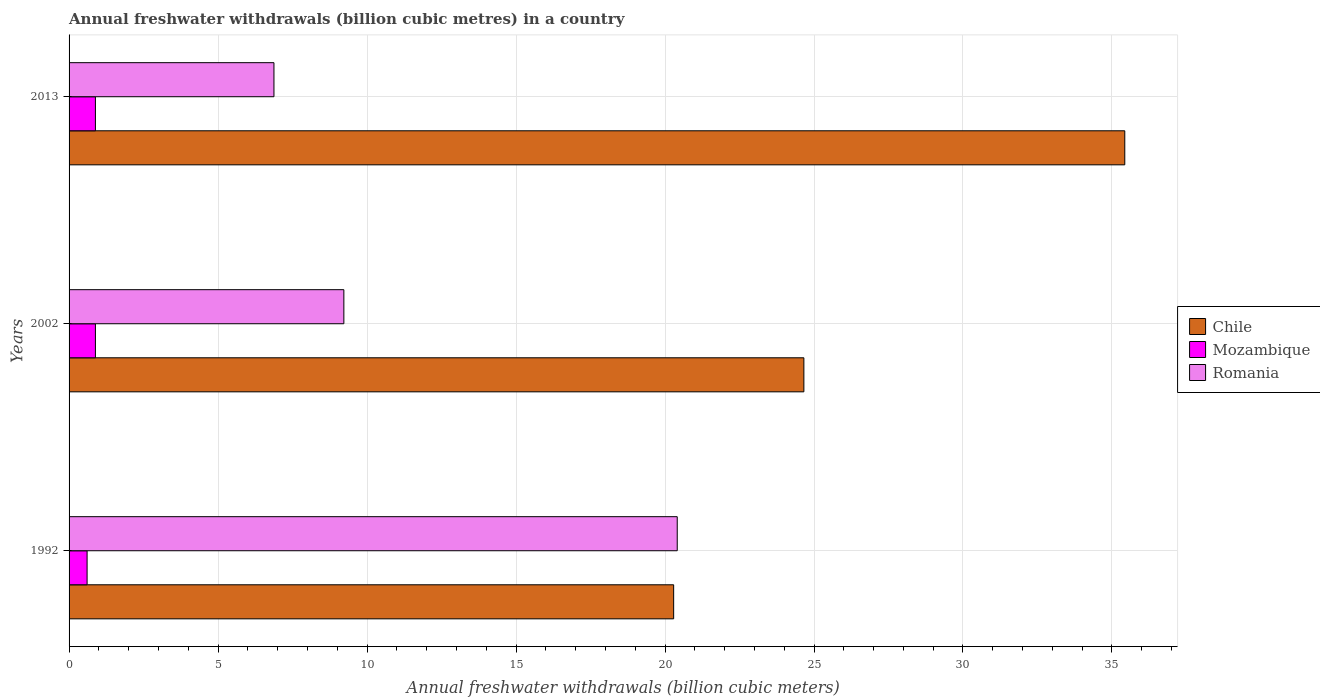How many different coloured bars are there?
Provide a succinct answer. 3. What is the annual freshwater withdrawals in Romania in 2013?
Provide a succinct answer. 6.88. Across all years, what is the maximum annual freshwater withdrawals in Mozambique?
Your answer should be very brief. 0.88. Across all years, what is the minimum annual freshwater withdrawals in Mozambique?
Ensure brevity in your answer.  0.6. In which year was the annual freshwater withdrawals in Romania minimum?
Offer a very short reply. 2013. What is the total annual freshwater withdrawals in Chile in the graph?
Provide a succinct answer. 80.38. What is the difference between the annual freshwater withdrawals in Chile in 1992 and that in 2002?
Make the answer very short. -4.37. What is the difference between the annual freshwater withdrawals in Romania in 2013 and the annual freshwater withdrawals in Chile in 2002?
Give a very brief answer. -17.78. What is the average annual freshwater withdrawals in Chile per year?
Provide a succinct answer. 26.79. In the year 1992, what is the difference between the annual freshwater withdrawals in Romania and annual freshwater withdrawals in Chile?
Your answer should be compact. 0.12. Is the annual freshwater withdrawals in Mozambique in 1992 less than that in 2002?
Your response must be concise. Yes. Is the difference between the annual freshwater withdrawals in Romania in 1992 and 2002 greater than the difference between the annual freshwater withdrawals in Chile in 1992 and 2002?
Provide a succinct answer. Yes. What is the difference between the highest and the second highest annual freshwater withdrawals in Chile?
Provide a short and direct response. 10.77. What is the difference between the highest and the lowest annual freshwater withdrawals in Chile?
Provide a succinct answer. 15.14. In how many years, is the annual freshwater withdrawals in Mozambique greater than the average annual freshwater withdrawals in Mozambique taken over all years?
Provide a short and direct response. 2. What does the 3rd bar from the bottom in 2013 represents?
Your answer should be compact. Romania. Is it the case that in every year, the sum of the annual freshwater withdrawals in Romania and annual freshwater withdrawals in Mozambique is greater than the annual freshwater withdrawals in Chile?
Make the answer very short. No. Are all the bars in the graph horizontal?
Offer a terse response. Yes. How many years are there in the graph?
Make the answer very short. 3. Are the values on the major ticks of X-axis written in scientific E-notation?
Provide a short and direct response. No. Does the graph contain any zero values?
Make the answer very short. No. Does the graph contain grids?
Provide a succinct answer. Yes. Where does the legend appear in the graph?
Offer a terse response. Center right. What is the title of the graph?
Your answer should be compact. Annual freshwater withdrawals (billion cubic metres) in a country. Does "Cameroon" appear as one of the legend labels in the graph?
Ensure brevity in your answer.  No. What is the label or title of the X-axis?
Offer a terse response. Annual freshwater withdrawals (billion cubic meters). What is the label or title of the Y-axis?
Offer a very short reply. Years. What is the Annual freshwater withdrawals (billion cubic meters) of Chile in 1992?
Offer a very short reply. 20.29. What is the Annual freshwater withdrawals (billion cubic meters) in Mozambique in 1992?
Ensure brevity in your answer.  0.6. What is the Annual freshwater withdrawals (billion cubic meters) of Romania in 1992?
Give a very brief answer. 20.41. What is the Annual freshwater withdrawals (billion cubic meters) in Chile in 2002?
Keep it short and to the point. 24.66. What is the Annual freshwater withdrawals (billion cubic meters) in Mozambique in 2002?
Provide a succinct answer. 0.88. What is the Annual freshwater withdrawals (billion cubic meters) in Romania in 2002?
Offer a terse response. 9.22. What is the Annual freshwater withdrawals (billion cubic meters) in Chile in 2013?
Provide a succinct answer. 35.43. What is the Annual freshwater withdrawals (billion cubic meters) of Mozambique in 2013?
Provide a short and direct response. 0.88. What is the Annual freshwater withdrawals (billion cubic meters) of Romania in 2013?
Your answer should be compact. 6.88. Across all years, what is the maximum Annual freshwater withdrawals (billion cubic meters) in Chile?
Keep it short and to the point. 35.43. Across all years, what is the maximum Annual freshwater withdrawals (billion cubic meters) in Mozambique?
Offer a very short reply. 0.88. Across all years, what is the maximum Annual freshwater withdrawals (billion cubic meters) in Romania?
Ensure brevity in your answer.  20.41. Across all years, what is the minimum Annual freshwater withdrawals (billion cubic meters) of Chile?
Provide a succinct answer. 20.29. Across all years, what is the minimum Annual freshwater withdrawals (billion cubic meters) in Mozambique?
Make the answer very short. 0.6. Across all years, what is the minimum Annual freshwater withdrawals (billion cubic meters) of Romania?
Provide a succinct answer. 6.88. What is the total Annual freshwater withdrawals (billion cubic meters) in Chile in the graph?
Your answer should be compact. 80.38. What is the total Annual freshwater withdrawals (billion cubic meters) of Mozambique in the graph?
Provide a succinct answer. 2.37. What is the total Annual freshwater withdrawals (billion cubic meters) of Romania in the graph?
Your answer should be very brief. 36.51. What is the difference between the Annual freshwater withdrawals (billion cubic meters) in Chile in 1992 and that in 2002?
Make the answer very short. -4.37. What is the difference between the Annual freshwater withdrawals (billion cubic meters) in Mozambique in 1992 and that in 2002?
Offer a very short reply. -0.28. What is the difference between the Annual freshwater withdrawals (billion cubic meters) in Romania in 1992 and that in 2002?
Keep it short and to the point. 11.19. What is the difference between the Annual freshwater withdrawals (billion cubic meters) of Chile in 1992 and that in 2013?
Make the answer very short. -15.14. What is the difference between the Annual freshwater withdrawals (billion cubic meters) in Mozambique in 1992 and that in 2013?
Your answer should be very brief. -0.28. What is the difference between the Annual freshwater withdrawals (billion cubic meters) in Romania in 1992 and that in 2013?
Keep it short and to the point. 13.53. What is the difference between the Annual freshwater withdrawals (billion cubic meters) of Chile in 2002 and that in 2013?
Offer a terse response. -10.77. What is the difference between the Annual freshwater withdrawals (billion cubic meters) of Romania in 2002 and that in 2013?
Your answer should be very brief. 2.35. What is the difference between the Annual freshwater withdrawals (billion cubic meters) of Chile in 1992 and the Annual freshwater withdrawals (billion cubic meters) of Mozambique in 2002?
Offer a terse response. 19.41. What is the difference between the Annual freshwater withdrawals (billion cubic meters) in Chile in 1992 and the Annual freshwater withdrawals (billion cubic meters) in Romania in 2002?
Offer a terse response. 11.07. What is the difference between the Annual freshwater withdrawals (billion cubic meters) in Mozambique in 1992 and the Annual freshwater withdrawals (billion cubic meters) in Romania in 2002?
Give a very brief answer. -8.62. What is the difference between the Annual freshwater withdrawals (billion cubic meters) of Chile in 1992 and the Annual freshwater withdrawals (billion cubic meters) of Mozambique in 2013?
Provide a succinct answer. 19.41. What is the difference between the Annual freshwater withdrawals (billion cubic meters) in Chile in 1992 and the Annual freshwater withdrawals (billion cubic meters) in Romania in 2013?
Keep it short and to the point. 13.41. What is the difference between the Annual freshwater withdrawals (billion cubic meters) in Mozambique in 1992 and the Annual freshwater withdrawals (billion cubic meters) in Romania in 2013?
Give a very brief answer. -6.27. What is the difference between the Annual freshwater withdrawals (billion cubic meters) in Chile in 2002 and the Annual freshwater withdrawals (billion cubic meters) in Mozambique in 2013?
Ensure brevity in your answer.  23.78. What is the difference between the Annual freshwater withdrawals (billion cubic meters) in Chile in 2002 and the Annual freshwater withdrawals (billion cubic meters) in Romania in 2013?
Offer a terse response. 17.78. What is the difference between the Annual freshwater withdrawals (billion cubic meters) in Mozambique in 2002 and the Annual freshwater withdrawals (billion cubic meters) in Romania in 2013?
Your answer should be compact. -5.99. What is the average Annual freshwater withdrawals (billion cubic meters) in Chile per year?
Ensure brevity in your answer.  26.79. What is the average Annual freshwater withdrawals (billion cubic meters) of Mozambique per year?
Provide a succinct answer. 0.79. What is the average Annual freshwater withdrawals (billion cubic meters) of Romania per year?
Your answer should be very brief. 12.17. In the year 1992, what is the difference between the Annual freshwater withdrawals (billion cubic meters) in Chile and Annual freshwater withdrawals (billion cubic meters) in Mozambique?
Make the answer very short. 19.68. In the year 1992, what is the difference between the Annual freshwater withdrawals (billion cubic meters) of Chile and Annual freshwater withdrawals (billion cubic meters) of Romania?
Keep it short and to the point. -0.12. In the year 1992, what is the difference between the Annual freshwater withdrawals (billion cubic meters) in Mozambique and Annual freshwater withdrawals (billion cubic meters) in Romania?
Provide a succinct answer. -19.8. In the year 2002, what is the difference between the Annual freshwater withdrawals (billion cubic meters) of Chile and Annual freshwater withdrawals (billion cubic meters) of Mozambique?
Make the answer very short. 23.78. In the year 2002, what is the difference between the Annual freshwater withdrawals (billion cubic meters) in Chile and Annual freshwater withdrawals (billion cubic meters) in Romania?
Offer a very short reply. 15.44. In the year 2002, what is the difference between the Annual freshwater withdrawals (billion cubic meters) in Mozambique and Annual freshwater withdrawals (billion cubic meters) in Romania?
Your response must be concise. -8.34. In the year 2013, what is the difference between the Annual freshwater withdrawals (billion cubic meters) in Chile and Annual freshwater withdrawals (billion cubic meters) in Mozambique?
Ensure brevity in your answer.  34.55. In the year 2013, what is the difference between the Annual freshwater withdrawals (billion cubic meters) in Chile and Annual freshwater withdrawals (billion cubic meters) in Romania?
Offer a very short reply. 28.55. In the year 2013, what is the difference between the Annual freshwater withdrawals (billion cubic meters) in Mozambique and Annual freshwater withdrawals (billion cubic meters) in Romania?
Your response must be concise. -5.99. What is the ratio of the Annual freshwater withdrawals (billion cubic meters) of Chile in 1992 to that in 2002?
Your response must be concise. 0.82. What is the ratio of the Annual freshwater withdrawals (billion cubic meters) in Mozambique in 1992 to that in 2002?
Your answer should be very brief. 0.68. What is the ratio of the Annual freshwater withdrawals (billion cubic meters) of Romania in 1992 to that in 2002?
Ensure brevity in your answer.  2.21. What is the ratio of the Annual freshwater withdrawals (billion cubic meters) of Chile in 1992 to that in 2013?
Your answer should be very brief. 0.57. What is the ratio of the Annual freshwater withdrawals (billion cubic meters) in Mozambique in 1992 to that in 2013?
Your answer should be very brief. 0.68. What is the ratio of the Annual freshwater withdrawals (billion cubic meters) in Romania in 1992 to that in 2013?
Your answer should be compact. 2.97. What is the ratio of the Annual freshwater withdrawals (billion cubic meters) in Chile in 2002 to that in 2013?
Offer a terse response. 0.7. What is the ratio of the Annual freshwater withdrawals (billion cubic meters) of Romania in 2002 to that in 2013?
Offer a very short reply. 1.34. What is the difference between the highest and the second highest Annual freshwater withdrawals (billion cubic meters) of Chile?
Your response must be concise. 10.77. What is the difference between the highest and the second highest Annual freshwater withdrawals (billion cubic meters) of Romania?
Offer a very short reply. 11.19. What is the difference between the highest and the lowest Annual freshwater withdrawals (billion cubic meters) in Chile?
Offer a very short reply. 15.14. What is the difference between the highest and the lowest Annual freshwater withdrawals (billion cubic meters) of Mozambique?
Your response must be concise. 0.28. What is the difference between the highest and the lowest Annual freshwater withdrawals (billion cubic meters) of Romania?
Your answer should be very brief. 13.53. 